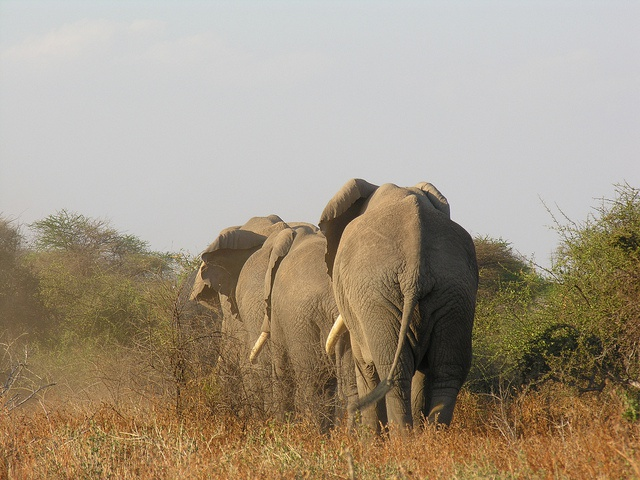Describe the objects in this image and their specific colors. I can see elephant in lightgray, black, tan, and gray tones, elephant in lightgray, tan, and gray tones, and elephant in lightgray, gray, and tan tones in this image. 